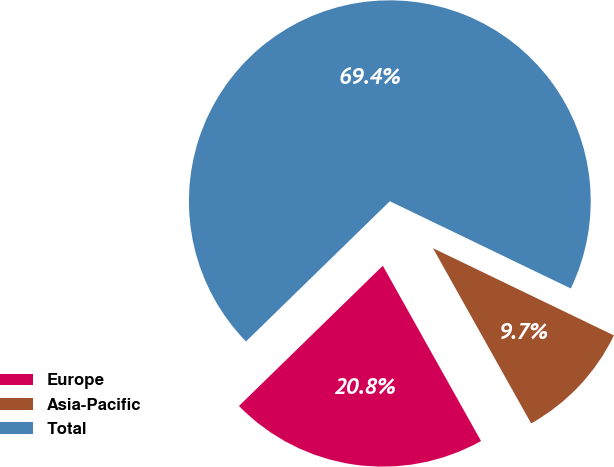<chart> <loc_0><loc_0><loc_500><loc_500><pie_chart><fcel>Europe<fcel>Asia-Pacific<fcel>Total<nl><fcel>20.83%<fcel>9.72%<fcel>69.44%<nl></chart> 